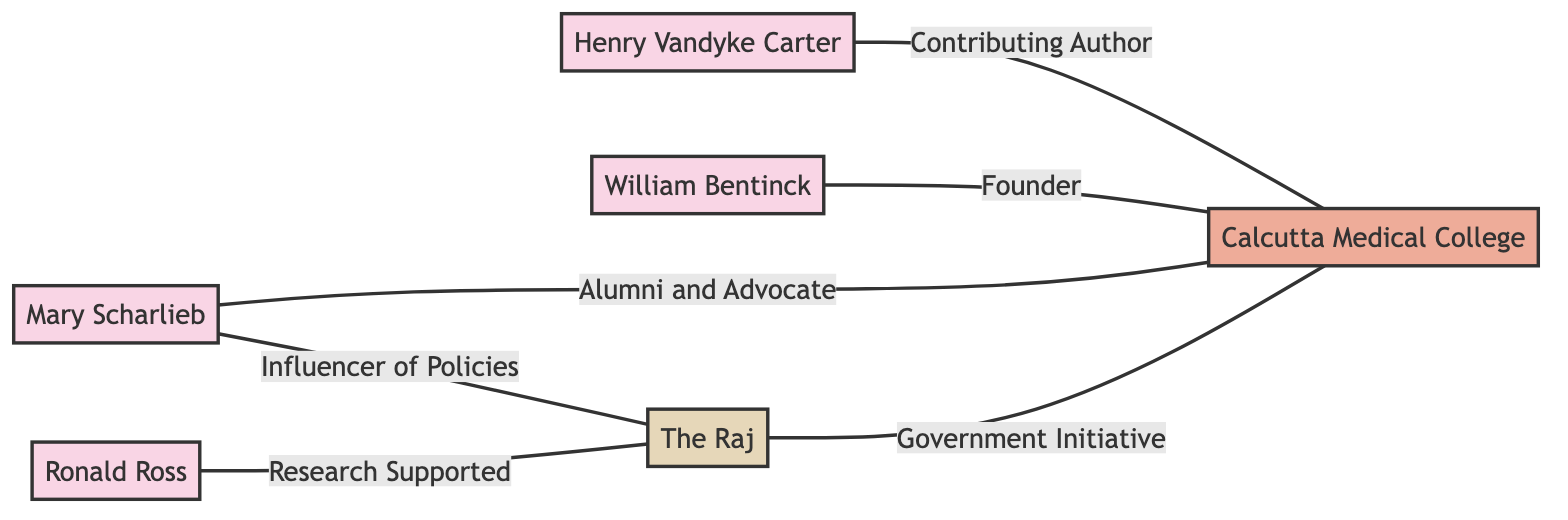What is the relationship between Henry Vandyke Carter and Calcutta Medical College? The diagram shows an edge connecting Henry Vandyke Carter and Calcutta Medical College with the label "Contributing Author," indicating their direct relationship in the context of the diagram.
Answer: Contributing Author Who is the founder of Calcutta Medical College? The diagram links William Bentinck to Calcutta Medical College with the relationship labeled "Founder," making it clear that he is the founder of this institution.
Answer: William Bentinck How many key figures are connected to Calcutta Medical College? The diagram displays three nodes directly connected to Calcutta Medical College: Henry Vandyke Carter, William Bentinck, and Mary Scharlieb, indicating that they are the key figures associated with this institution.
Answer: 3 What was Mary Scharlieb's role in relation to The Raj? The diagram illustrates that Mary Scharlieb has a connection to The Raj with the relationship described as "Influencer of Policies," indicating her influence on healthcare policies during the colonial period.
Answer: Influencer of Policies Which figure's research was supported by The Raj? The diagram clearly indicates a connection between Ronald Ross and The Raj labeled "Research Supported," showcasing that Ronald Ross received support from The Raj for his research.
Answer: Ronald Ross How many relationships involve The Raj? The diagram shows two relationships involving The Raj: one is with Ronald Ross ("Research Supported") and the other is with Calcutta Medical College ("Government Initiative"). This leads to the conclusion of the total number of relationships.
Answer: 2 What role did Mary Scharlieb have at Calcutta Medical College? The diagram connects Mary Scharlieb to Calcutta Medical College with the relationship "Alumni and Advocate," indicating her role as an advocate while being an alumna of the institution.
Answer: Alumni and Advocate Who discovered the malaria parasite in mosquitoes? The diagram identifies Ronald Ross and connects him through his research supported by The Raj, which connects him to the discovery of the malaria parasite, representing a significant advancement in tropical medicine.
Answer: Ronald Ross What type of institution is Calcutta Medical College? Based on the classification in the diagram and the description provided, Calcutta Medical College is categorized as an institution, crucial for the training of physicians in South Asia.
Answer: Institution 